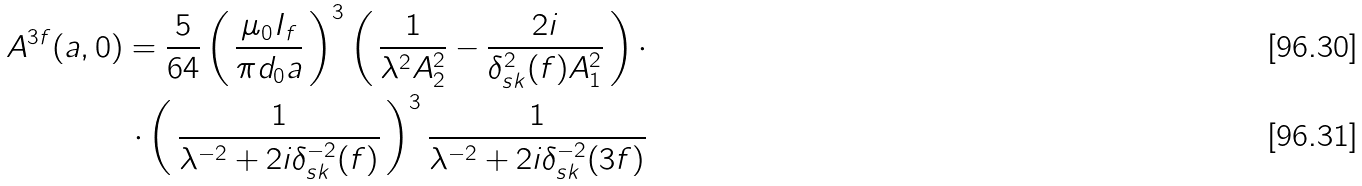<formula> <loc_0><loc_0><loc_500><loc_500>A ^ { 3 f } ( a , 0 ) = \frac { 5 } { 6 4 } \left ( \, \frac { \mu _ { 0 } I _ { f } } { \pi d _ { 0 } a } \, \right ) ^ { 3 } \left ( \, \frac { 1 } { \lambda ^ { 2 } A _ { 2 } ^ { 2 } } - \frac { 2 i } { \delta _ { s k } ^ { 2 } ( f ) A _ { 1 } ^ { 2 } } \, \right ) \cdot \\ \cdot \left ( \, \frac { 1 } { \lambda ^ { - 2 } + 2 i \delta _ { s k } ^ { - 2 } ( f ) } \, \right ) ^ { 3 } \frac { 1 } { \lambda ^ { - 2 } + 2 i \delta _ { s k } ^ { - 2 } ( 3 f ) }</formula> 